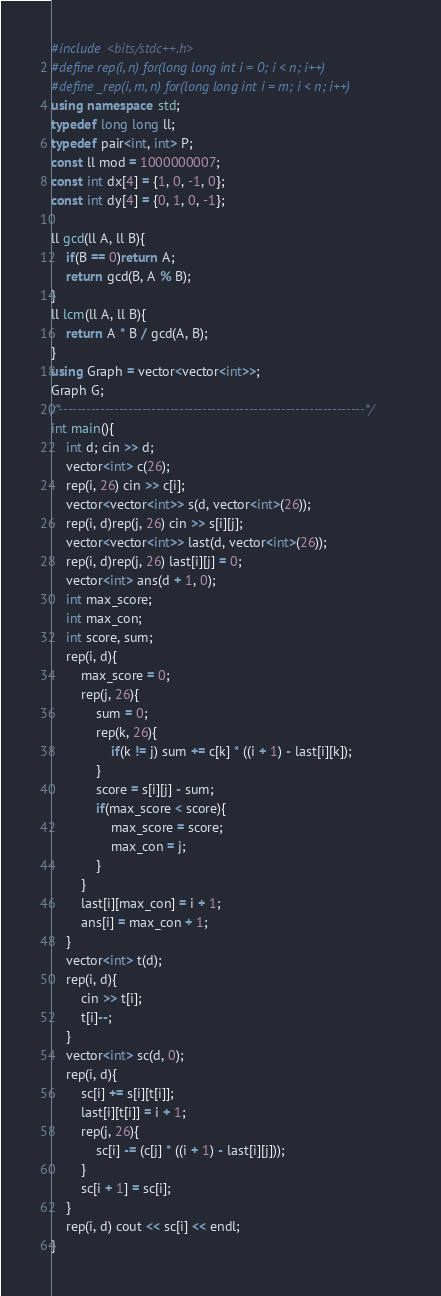Convert code to text. <code><loc_0><loc_0><loc_500><loc_500><_C++_>#include <bits/stdc++.h>
#define rep(i, n) for(long long int i = 0; i < n; i++)
#define _rep(i, m, n) for(long long int i = m; i < n; i++)
using namespace std;
typedef long long ll;
typedef pair<int, int> P;
const ll mod = 1000000007;
const int dx[4] = {1, 0, -1, 0};
const int dy[4] = {0, 1, 0, -1};

ll gcd(ll A, ll B){
    if(B == 0)return A;
    return gcd(B, A % B);
}
ll lcm(ll A, ll B){
    return A * B / gcd(A, B);
}
using Graph = vector<vector<int>>;
Graph G;
/*------------------------------------------------------------------*/
int main(){
    int d; cin >> d;
    vector<int> c(26);
    rep(i, 26) cin >> c[i];
    vector<vector<int>> s(d, vector<int>(26));
    rep(i, d)rep(j, 26) cin >> s[i][j];
    vector<vector<int>> last(d, vector<int>(26));
    rep(i, d)rep(j, 26) last[i][j] = 0;
    vector<int> ans(d + 1, 0);
    int max_score;
    int max_con;
    int score, sum;
    rep(i, d){
        max_score = 0;
        rep(j, 26){
            sum = 0;
            rep(k, 26){
                if(k != j) sum += c[k] * ((i + 1) - last[i][k]);
            }
            score = s[i][j] - sum;
            if(max_score < score){
                max_score = score;
                max_con = j;
            }
        }
        last[i][max_con] = i + 1;
        ans[i] = max_con + 1;
    }
    vector<int> t(d);
    rep(i, d){
        cin >> t[i];
        t[i]--;
    }
    vector<int> sc(d, 0);
    rep(i, d){
        sc[i] += s[i][t[i]];
        last[i][t[i]] = i + 1;
        rep(j, 26){
            sc[i] -= (c[j] * ((i + 1) - last[i][j])); 
        }
        sc[i + 1] = sc[i];
    }
    rep(i, d) cout << sc[i] << endl;
}
</code> 